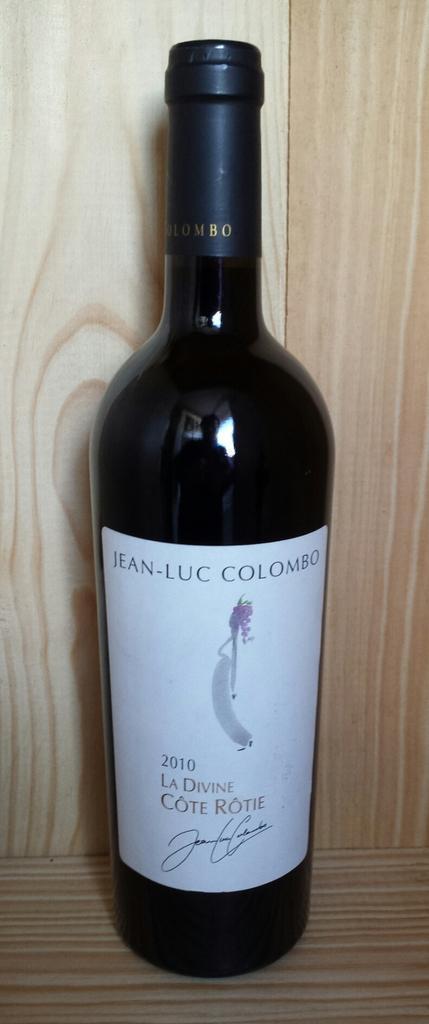Describe this image in one or two sentences. In the center of the picture there is a liquor bottle, on the bottle there is a white sticker. The bottle is placed in a wooden object. 